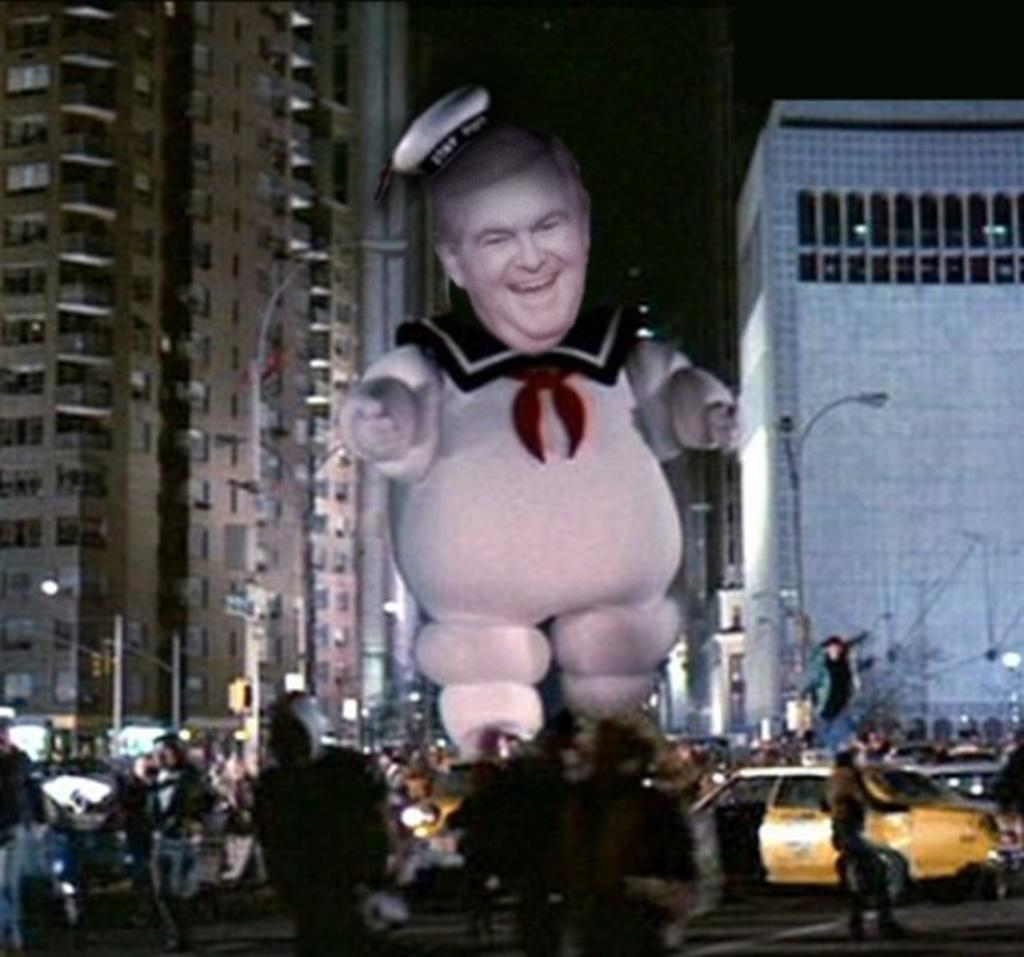What is the main subject in the image? There is a statue in the image. What is happening at the bottom of the image? People are visible at the bottom of the image, and cars are present on the road. What can be seen in the background of the image? Buildings and poles are visible in the background of the image. Where is the cactus located in the image? There is no cactus present in the image. What type of jewel is the statue holding in the image? The statue is not holding any jewel in the image. 